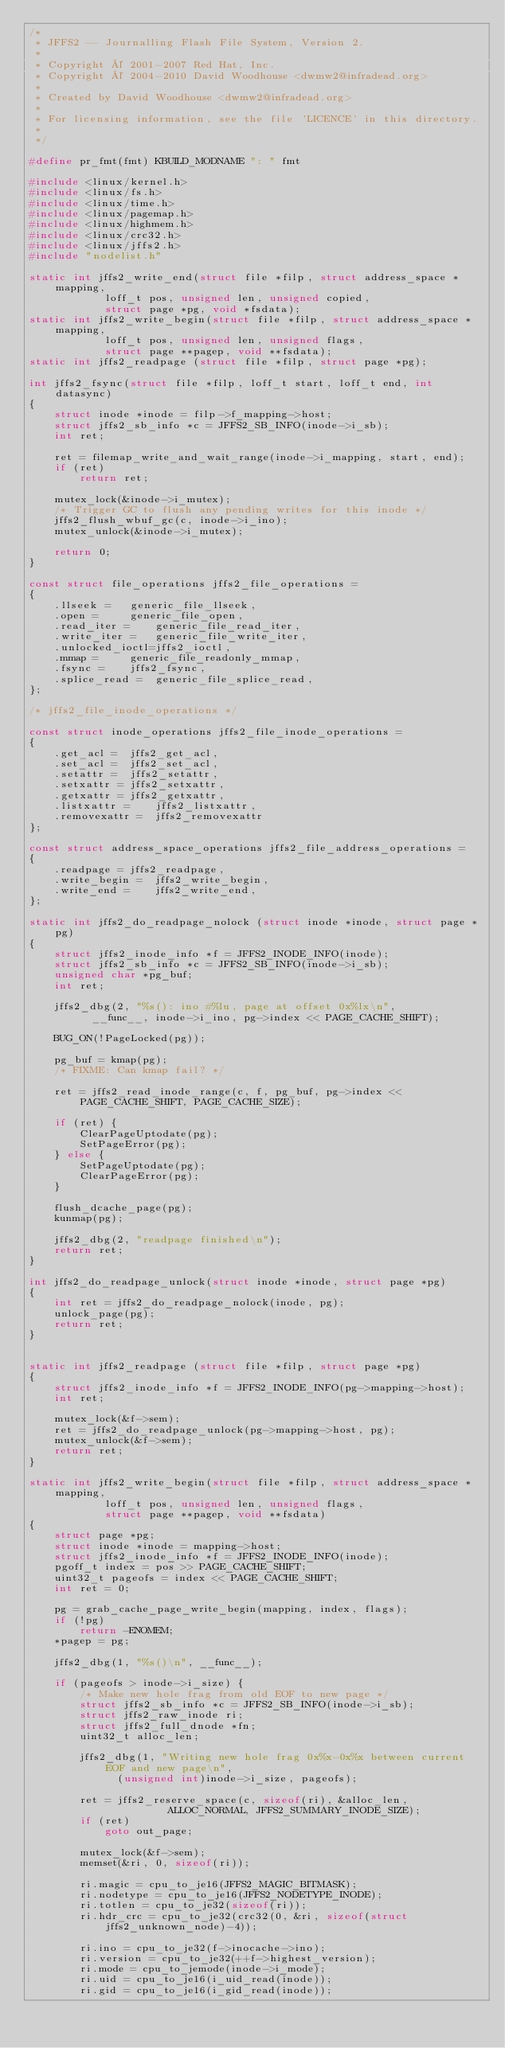Convert code to text. <code><loc_0><loc_0><loc_500><loc_500><_C_>/*
 * JFFS2 -- Journalling Flash File System, Version 2.
 *
 * Copyright © 2001-2007 Red Hat, Inc.
 * Copyright © 2004-2010 David Woodhouse <dwmw2@infradead.org>
 *
 * Created by David Woodhouse <dwmw2@infradead.org>
 *
 * For licensing information, see the file 'LICENCE' in this directory.
 *
 */

#define pr_fmt(fmt) KBUILD_MODNAME ": " fmt

#include <linux/kernel.h>
#include <linux/fs.h>
#include <linux/time.h>
#include <linux/pagemap.h>
#include <linux/highmem.h>
#include <linux/crc32.h>
#include <linux/jffs2.h>
#include "nodelist.h"

static int jffs2_write_end(struct file *filp, struct address_space *mapping,
			loff_t pos, unsigned len, unsigned copied,
			struct page *pg, void *fsdata);
static int jffs2_write_begin(struct file *filp, struct address_space *mapping,
			loff_t pos, unsigned len, unsigned flags,
			struct page **pagep, void **fsdata);
static int jffs2_readpage (struct file *filp, struct page *pg);

int jffs2_fsync(struct file *filp, loff_t start, loff_t end, int datasync)
{
	struct inode *inode = filp->f_mapping->host;
	struct jffs2_sb_info *c = JFFS2_SB_INFO(inode->i_sb);
	int ret;

	ret = filemap_write_and_wait_range(inode->i_mapping, start, end);
	if (ret)
		return ret;

	mutex_lock(&inode->i_mutex);
	/* Trigger GC to flush any pending writes for this inode */
	jffs2_flush_wbuf_gc(c, inode->i_ino);
	mutex_unlock(&inode->i_mutex);

	return 0;
}

const struct file_operations jffs2_file_operations =
{
	.llseek =	generic_file_llseek,
	.open =		generic_file_open,
 	.read_iter =	generic_file_read_iter,
 	.write_iter =	generic_file_write_iter,
	.unlocked_ioctl=jffs2_ioctl,
	.mmap =		generic_file_readonly_mmap,
	.fsync =	jffs2_fsync,
	.splice_read =	generic_file_splice_read,
};

/* jffs2_file_inode_operations */

const struct inode_operations jffs2_file_inode_operations =
{
	.get_acl =	jffs2_get_acl,
	.set_acl =	jffs2_set_acl,
	.setattr =	jffs2_setattr,
	.setxattr =	jffs2_setxattr,
	.getxattr =	jffs2_getxattr,
	.listxattr =	jffs2_listxattr,
	.removexattr =	jffs2_removexattr
};

const struct address_space_operations jffs2_file_address_operations =
{
	.readpage =	jffs2_readpage,
	.write_begin =	jffs2_write_begin,
	.write_end =	jffs2_write_end,
};

static int jffs2_do_readpage_nolock (struct inode *inode, struct page *pg)
{
	struct jffs2_inode_info *f = JFFS2_INODE_INFO(inode);
	struct jffs2_sb_info *c = JFFS2_SB_INFO(inode->i_sb);
	unsigned char *pg_buf;
	int ret;

	jffs2_dbg(2, "%s(): ino #%lu, page at offset 0x%lx\n",
		  __func__, inode->i_ino, pg->index << PAGE_CACHE_SHIFT);

	BUG_ON(!PageLocked(pg));

	pg_buf = kmap(pg);
	/* FIXME: Can kmap fail? */

	ret = jffs2_read_inode_range(c, f, pg_buf, pg->index << PAGE_CACHE_SHIFT, PAGE_CACHE_SIZE);

	if (ret) {
		ClearPageUptodate(pg);
		SetPageError(pg);
	} else {
		SetPageUptodate(pg);
		ClearPageError(pg);
	}

	flush_dcache_page(pg);
	kunmap(pg);

	jffs2_dbg(2, "readpage finished\n");
	return ret;
}

int jffs2_do_readpage_unlock(struct inode *inode, struct page *pg)
{
	int ret = jffs2_do_readpage_nolock(inode, pg);
	unlock_page(pg);
	return ret;
}


static int jffs2_readpage (struct file *filp, struct page *pg)
{
	struct jffs2_inode_info *f = JFFS2_INODE_INFO(pg->mapping->host);
	int ret;

	mutex_lock(&f->sem);
	ret = jffs2_do_readpage_unlock(pg->mapping->host, pg);
	mutex_unlock(&f->sem);
	return ret;
}

static int jffs2_write_begin(struct file *filp, struct address_space *mapping,
			loff_t pos, unsigned len, unsigned flags,
			struct page **pagep, void **fsdata)
{
	struct page *pg;
	struct inode *inode = mapping->host;
	struct jffs2_inode_info *f = JFFS2_INODE_INFO(inode);
	pgoff_t index = pos >> PAGE_CACHE_SHIFT;
	uint32_t pageofs = index << PAGE_CACHE_SHIFT;
	int ret = 0;

	pg = grab_cache_page_write_begin(mapping, index, flags);
	if (!pg)
		return -ENOMEM;
	*pagep = pg;

	jffs2_dbg(1, "%s()\n", __func__);

	if (pageofs > inode->i_size) {
		/* Make new hole frag from old EOF to new page */
		struct jffs2_sb_info *c = JFFS2_SB_INFO(inode->i_sb);
		struct jffs2_raw_inode ri;
		struct jffs2_full_dnode *fn;
		uint32_t alloc_len;

		jffs2_dbg(1, "Writing new hole frag 0x%x-0x%x between current EOF and new page\n",
			  (unsigned int)inode->i_size, pageofs);

		ret = jffs2_reserve_space(c, sizeof(ri), &alloc_len,
					  ALLOC_NORMAL, JFFS2_SUMMARY_INODE_SIZE);
		if (ret)
			goto out_page;

		mutex_lock(&f->sem);
		memset(&ri, 0, sizeof(ri));

		ri.magic = cpu_to_je16(JFFS2_MAGIC_BITMASK);
		ri.nodetype = cpu_to_je16(JFFS2_NODETYPE_INODE);
		ri.totlen = cpu_to_je32(sizeof(ri));
		ri.hdr_crc = cpu_to_je32(crc32(0, &ri, sizeof(struct jffs2_unknown_node)-4));

		ri.ino = cpu_to_je32(f->inocache->ino);
		ri.version = cpu_to_je32(++f->highest_version);
		ri.mode = cpu_to_jemode(inode->i_mode);
		ri.uid = cpu_to_je16(i_uid_read(inode));
		ri.gid = cpu_to_je16(i_gid_read(inode));</code> 